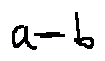<formula> <loc_0><loc_0><loc_500><loc_500>a = b</formula> 